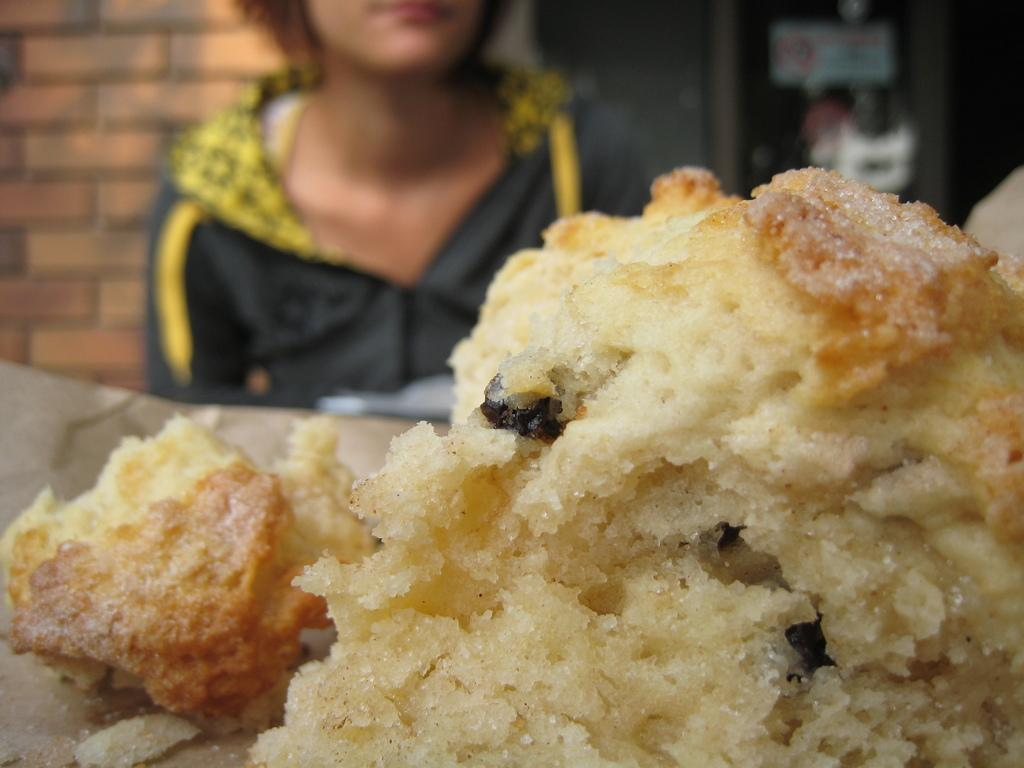What is the main subject of the image? The main subject of the image is food items on a table. Can you describe the food items on the table? Unfortunately, the facts provided do not give specific details about the food items on the table. Is there anyone else in the image besides the food items? Yes, there is a person in the background of the image, although they are blurry. What type of farmer is depicted in the image? There is no farmer present in the image; it features food items on a table and a blurry person in the background. What message does the love flag in the image convey? There is no love flag or any flag present in the image. 